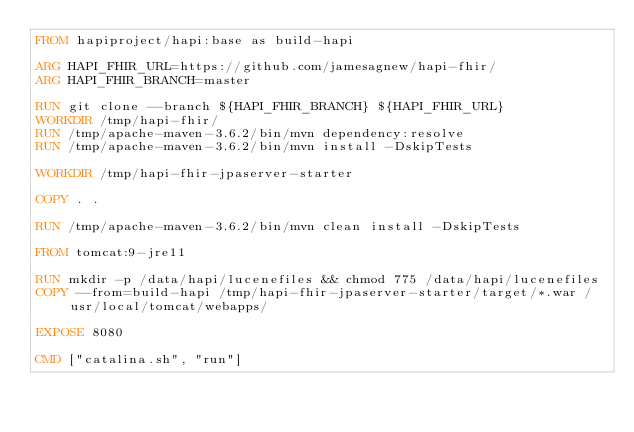<code> <loc_0><loc_0><loc_500><loc_500><_Dockerfile_>FROM hapiproject/hapi:base as build-hapi

ARG HAPI_FHIR_URL=https://github.com/jamesagnew/hapi-fhir/
ARG HAPI_FHIR_BRANCH=master

RUN git clone --branch ${HAPI_FHIR_BRANCH} ${HAPI_FHIR_URL}
WORKDIR /tmp/hapi-fhir/
RUN /tmp/apache-maven-3.6.2/bin/mvn dependency:resolve
RUN /tmp/apache-maven-3.6.2/bin/mvn install -DskipTests

WORKDIR /tmp/hapi-fhir-jpaserver-starter

COPY . .

RUN /tmp/apache-maven-3.6.2/bin/mvn clean install -DskipTests

FROM tomcat:9-jre11

RUN mkdir -p /data/hapi/lucenefiles && chmod 775 /data/hapi/lucenefiles
COPY --from=build-hapi /tmp/hapi-fhir-jpaserver-starter/target/*.war /usr/local/tomcat/webapps/

EXPOSE 8080

CMD ["catalina.sh", "run"]</code> 